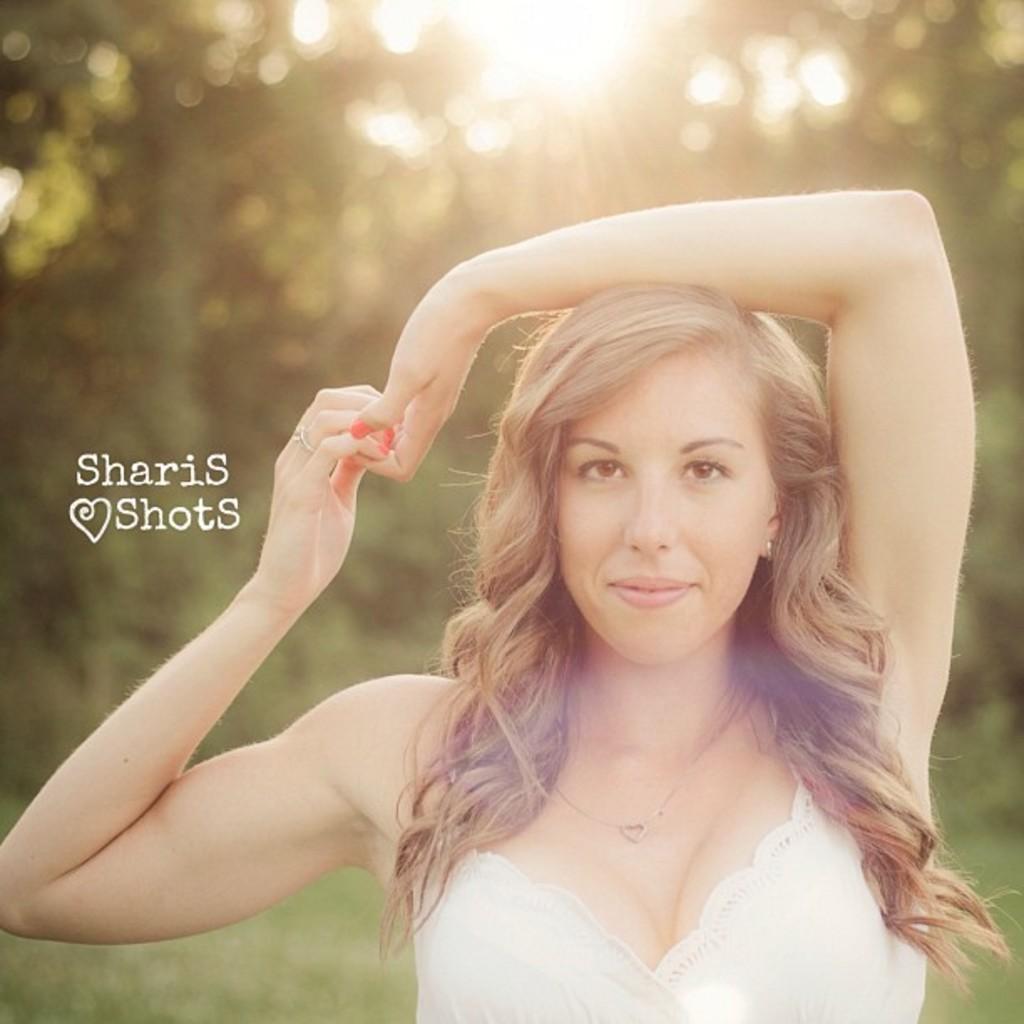Please provide a concise description of this image. In this image in front there is a person. At the bottom of the image there is grass on the surface. In the background of the image there are trees and there is sun. There is some text on the left side of the image. 